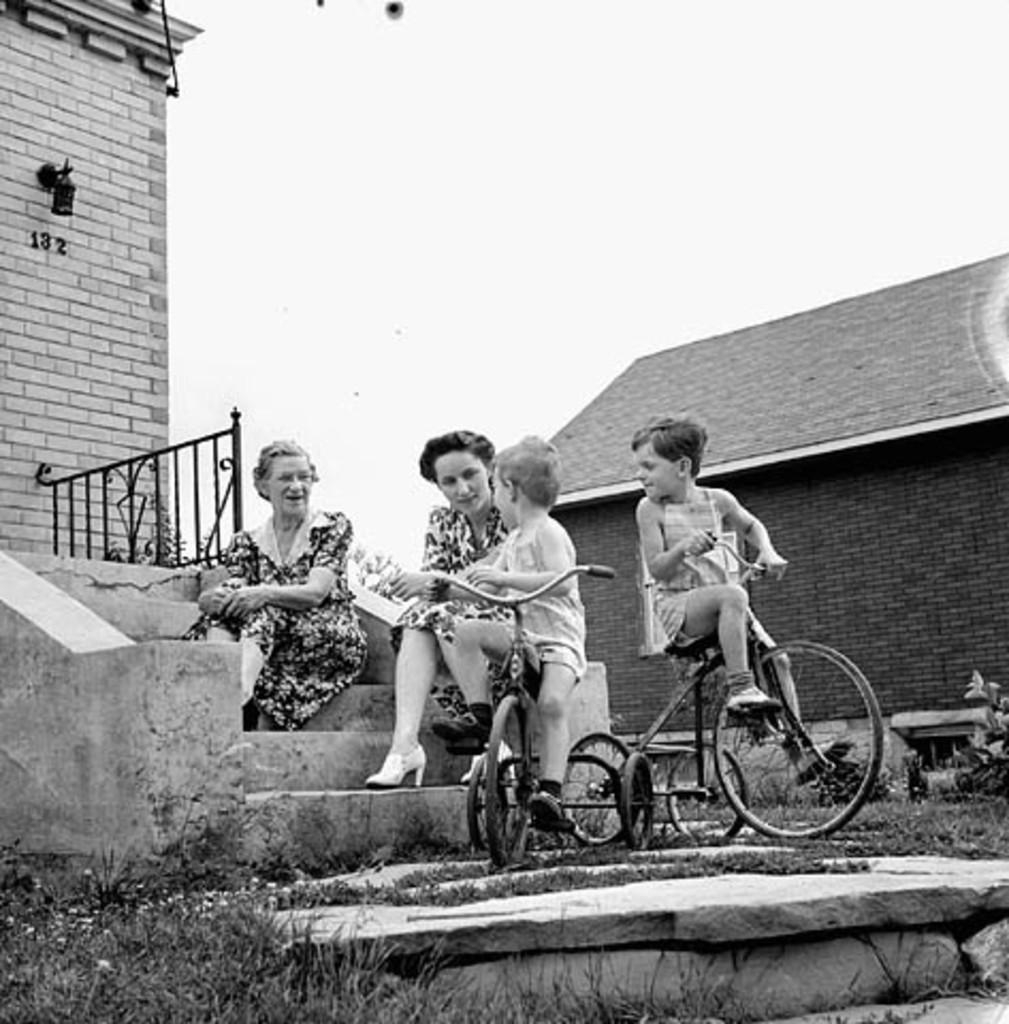Can you describe this image briefly? It is a black and white image. In this image, we can be two women are sitting on the stairs. Here we can see two kids are sitting on the vehicle seats. At the bottom, we can see plants, grass and stone. Background we can see walls, horses, grill and sky. Here we few numbers and object. 